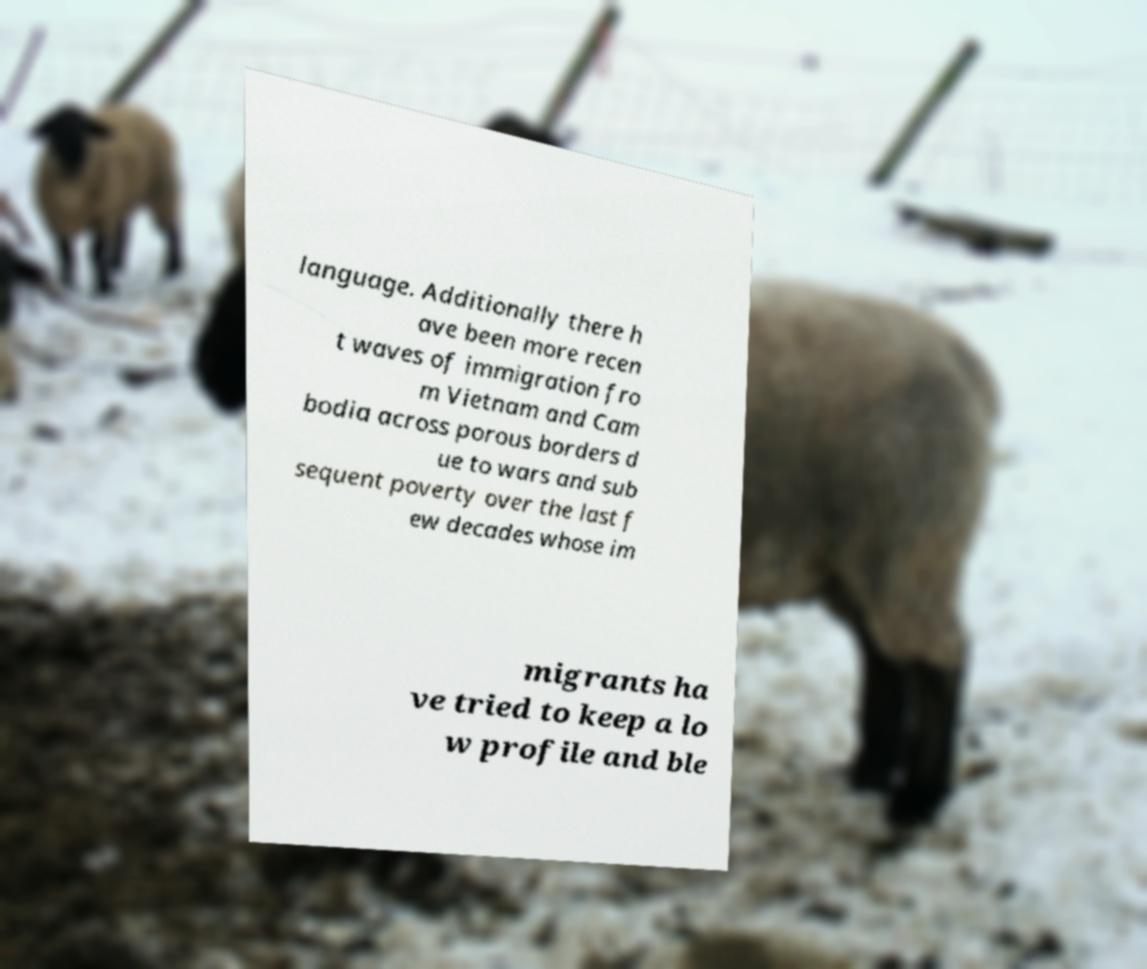Could you assist in decoding the text presented in this image and type it out clearly? language. Additionally there h ave been more recen t waves of immigration fro m Vietnam and Cam bodia across porous borders d ue to wars and sub sequent poverty over the last f ew decades whose im migrants ha ve tried to keep a lo w profile and ble 